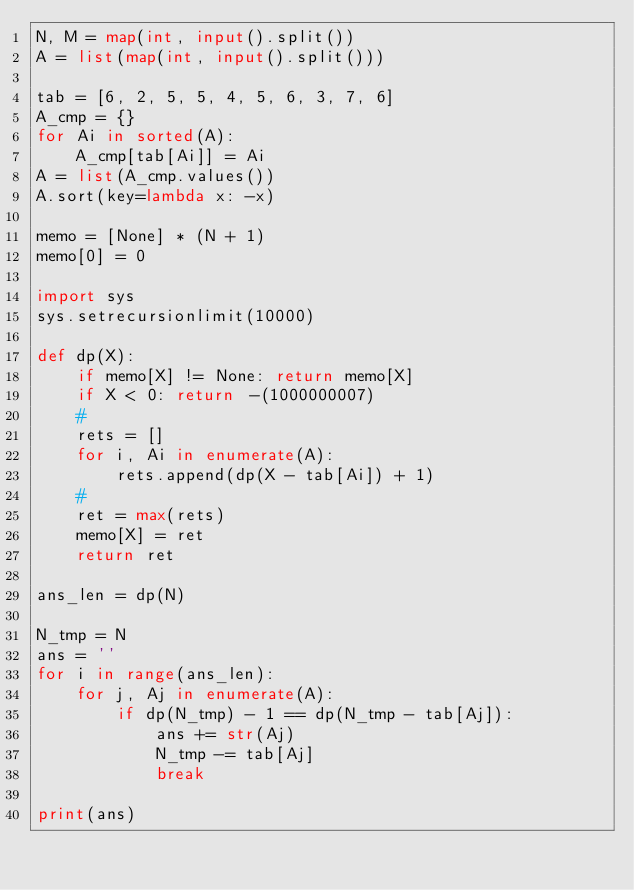Convert code to text. <code><loc_0><loc_0><loc_500><loc_500><_Python_>N, M = map(int, input().split())
A = list(map(int, input().split()))

tab = [6, 2, 5, 5, 4, 5, 6, 3, 7, 6]
A_cmp = {}
for Ai in sorted(A):
    A_cmp[tab[Ai]] = Ai
A = list(A_cmp.values())
A.sort(key=lambda x: -x)

memo = [None] * (N + 1)
memo[0] = 0

import sys
sys.setrecursionlimit(10000)

def dp(X):
    if memo[X] != None: return memo[X]
    if X < 0: return -(1000000007)
    #
    rets = []
    for i, Ai in enumerate(A):
        rets.append(dp(X - tab[Ai]) + 1)
    #
    ret = max(rets)
    memo[X] = ret
    return ret

ans_len = dp(N)

N_tmp = N
ans = ''
for i in range(ans_len):
    for j, Aj in enumerate(A):
        if dp(N_tmp) - 1 == dp(N_tmp - tab[Aj]):
            ans += str(Aj)
            N_tmp -= tab[Aj]
            break

print(ans)</code> 